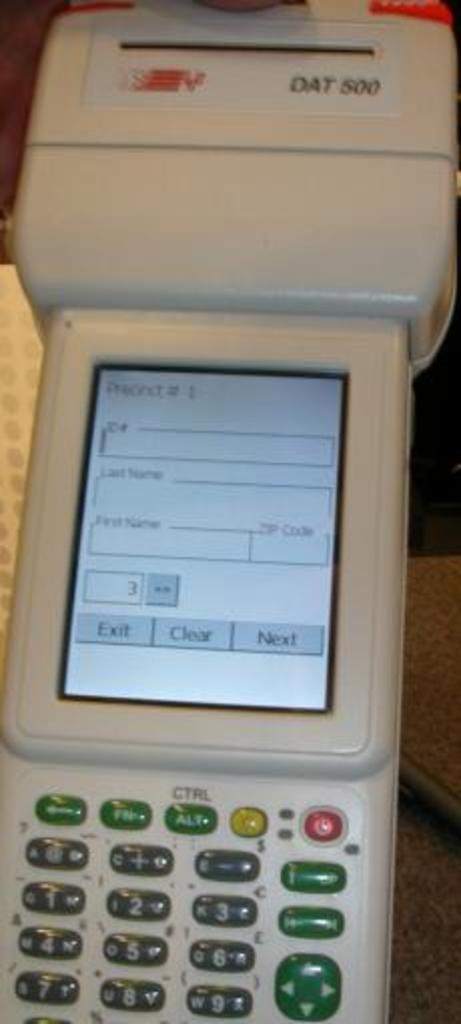<image>
Summarize the visual content of the image. The DAT 500 has a display and a keypad. 